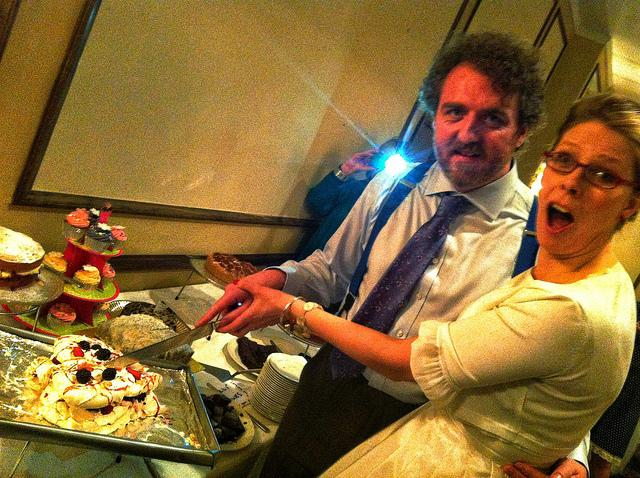Why is the man behind the other two holding a flashing object?

Choices:
A) being annoying
B) making art
C) being funny
D) taking pictures taking pictures 